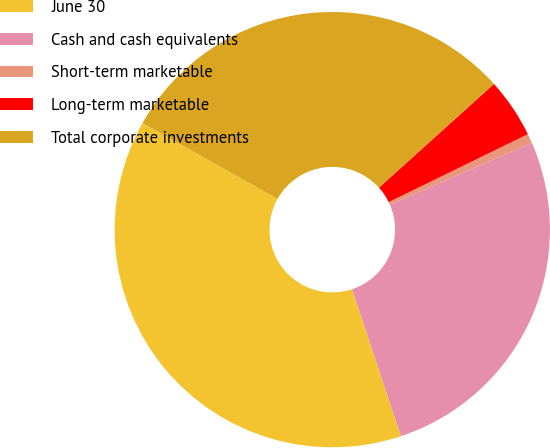Convert chart to OTSL. <chart><loc_0><loc_0><loc_500><loc_500><pie_chart><fcel>June 30<fcel>Cash and cash equivalents<fcel>Short-term marketable<fcel>Long-term marketable<fcel>Total corporate investments<nl><fcel>38.25%<fcel>26.43%<fcel>0.69%<fcel>4.45%<fcel>30.18%<nl></chart> 